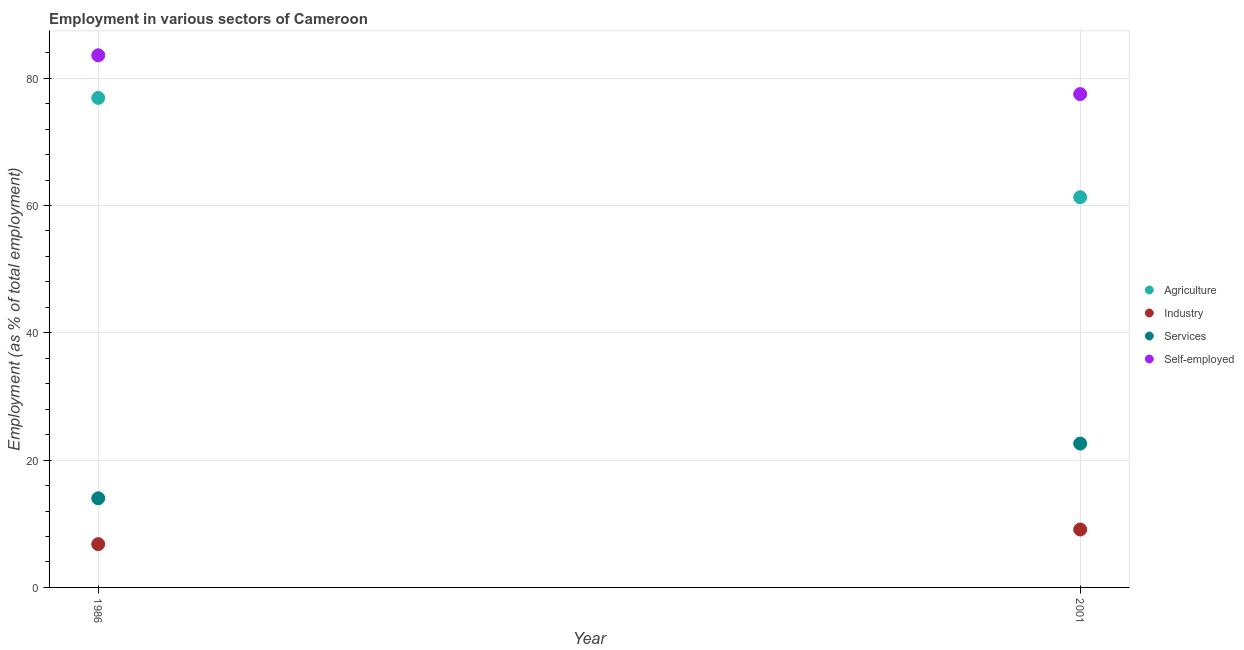How many different coloured dotlines are there?
Provide a succinct answer. 4. Is the number of dotlines equal to the number of legend labels?
Provide a succinct answer. Yes. What is the percentage of workers in industry in 1986?
Make the answer very short. 6.8. Across all years, what is the maximum percentage of workers in services?
Give a very brief answer. 22.6. Across all years, what is the minimum percentage of workers in industry?
Offer a very short reply. 6.8. In which year was the percentage of workers in services maximum?
Ensure brevity in your answer.  2001. In which year was the percentage of workers in services minimum?
Provide a succinct answer. 1986. What is the total percentage of workers in industry in the graph?
Provide a succinct answer. 15.9. What is the difference between the percentage of workers in industry in 1986 and that in 2001?
Give a very brief answer. -2.3. What is the difference between the percentage of workers in industry in 2001 and the percentage of self employed workers in 1986?
Your answer should be very brief. -74.5. What is the average percentage of workers in services per year?
Give a very brief answer. 18.3. In the year 1986, what is the difference between the percentage of self employed workers and percentage of workers in services?
Offer a terse response. 69.6. What is the ratio of the percentage of workers in agriculture in 1986 to that in 2001?
Give a very brief answer. 1.25. Is it the case that in every year, the sum of the percentage of self employed workers and percentage of workers in services is greater than the sum of percentage of workers in industry and percentage of workers in agriculture?
Provide a succinct answer. No. Is it the case that in every year, the sum of the percentage of workers in agriculture and percentage of workers in industry is greater than the percentage of workers in services?
Offer a terse response. Yes. Does the percentage of self employed workers monotonically increase over the years?
Keep it short and to the point. No. Is the percentage of self employed workers strictly greater than the percentage of workers in industry over the years?
Your answer should be very brief. Yes. How many dotlines are there?
Keep it short and to the point. 4. Are the values on the major ticks of Y-axis written in scientific E-notation?
Offer a very short reply. No. Does the graph contain any zero values?
Your answer should be compact. No. Where does the legend appear in the graph?
Make the answer very short. Center right. How many legend labels are there?
Your answer should be very brief. 4. What is the title of the graph?
Give a very brief answer. Employment in various sectors of Cameroon. What is the label or title of the X-axis?
Give a very brief answer. Year. What is the label or title of the Y-axis?
Your response must be concise. Employment (as % of total employment). What is the Employment (as % of total employment) of Agriculture in 1986?
Offer a very short reply. 76.9. What is the Employment (as % of total employment) of Industry in 1986?
Offer a very short reply. 6.8. What is the Employment (as % of total employment) of Services in 1986?
Ensure brevity in your answer.  14. What is the Employment (as % of total employment) of Self-employed in 1986?
Give a very brief answer. 83.6. What is the Employment (as % of total employment) in Agriculture in 2001?
Make the answer very short. 61.3. What is the Employment (as % of total employment) in Industry in 2001?
Offer a terse response. 9.1. What is the Employment (as % of total employment) of Services in 2001?
Provide a succinct answer. 22.6. What is the Employment (as % of total employment) of Self-employed in 2001?
Offer a very short reply. 77.5. Across all years, what is the maximum Employment (as % of total employment) of Agriculture?
Keep it short and to the point. 76.9. Across all years, what is the maximum Employment (as % of total employment) of Industry?
Offer a terse response. 9.1. Across all years, what is the maximum Employment (as % of total employment) of Services?
Give a very brief answer. 22.6. Across all years, what is the maximum Employment (as % of total employment) in Self-employed?
Offer a terse response. 83.6. Across all years, what is the minimum Employment (as % of total employment) in Agriculture?
Give a very brief answer. 61.3. Across all years, what is the minimum Employment (as % of total employment) of Industry?
Offer a terse response. 6.8. Across all years, what is the minimum Employment (as % of total employment) in Services?
Keep it short and to the point. 14. Across all years, what is the minimum Employment (as % of total employment) of Self-employed?
Provide a succinct answer. 77.5. What is the total Employment (as % of total employment) in Agriculture in the graph?
Your answer should be very brief. 138.2. What is the total Employment (as % of total employment) in Industry in the graph?
Make the answer very short. 15.9. What is the total Employment (as % of total employment) in Services in the graph?
Your answer should be compact. 36.6. What is the total Employment (as % of total employment) of Self-employed in the graph?
Ensure brevity in your answer.  161.1. What is the difference between the Employment (as % of total employment) in Self-employed in 1986 and that in 2001?
Make the answer very short. 6.1. What is the difference between the Employment (as % of total employment) of Agriculture in 1986 and the Employment (as % of total employment) of Industry in 2001?
Give a very brief answer. 67.8. What is the difference between the Employment (as % of total employment) in Agriculture in 1986 and the Employment (as % of total employment) in Services in 2001?
Your answer should be very brief. 54.3. What is the difference between the Employment (as % of total employment) in Industry in 1986 and the Employment (as % of total employment) in Services in 2001?
Ensure brevity in your answer.  -15.8. What is the difference between the Employment (as % of total employment) of Industry in 1986 and the Employment (as % of total employment) of Self-employed in 2001?
Your answer should be very brief. -70.7. What is the difference between the Employment (as % of total employment) of Services in 1986 and the Employment (as % of total employment) of Self-employed in 2001?
Give a very brief answer. -63.5. What is the average Employment (as % of total employment) of Agriculture per year?
Keep it short and to the point. 69.1. What is the average Employment (as % of total employment) in Industry per year?
Offer a terse response. 7.95. What is the average Employment (as % of total employment) in Services per year?
Give a very brief answer. 18.3. What is the average Employment (as % of total employment) in Self-employed per year?
Provide a short and direct response. 80.55. In the year 1986, what is the difference between the Employment (as % of total employment) in Agriculture and Employment (as % of total employment) in Industry?
Your answer should be very brief. 70.1. In the year 1986, what is the difference between the Employment (as % of total employment) of Agriculture and Employment (as % of total employment) of Services?
Keep it short and to the point. 62.9. In the year 1986, what is the difference between the Employment (as % of total employment) of Industry and Employment (as % of total employment) of Services?
Make the answer very short. -7.2. In the year 1986, what is the difference between the Employment (as % of total employment) in Industry and Employment (as % of total employment) in Self-employed?
Your answer should be very brief. -76.8. In the year 1986, what is the difference between the Employment (as % of total employment) of Services and Employment (as % of total employment) of Self-employed?
Your response must be concise. -69.6. In the year 2001, what is the difference between the Employment (as % of total employment) of Agriculture and Employment (as % of total employment) of Industry?
Your answer should be compact. 52.2. In the year 2001, what is the difference between the Employment (as % of total employment) of Agriculture and Employment (as % of total employment) of Services?
Provide a short and direct response. 38.7. In the year 2001, what is the difference between the Employment (as % of total employment) in Agriculture and Employment (as % of total employment) in Self-employed?
Ensure brevity in your answer.  -16.2. In the year 2001, what is the difference between the Employment (as % of total employment) of Industry and Employment (as % of total employment) of Services?
Provide a succinct answer. -13.5. In the year 2001, what is the difference between the Employment (as % of total employment) in Industry and Employment (as % of total employment) in Self-employed?
Keep it short and to the point. -68.4. In the year 2001, what is the difference between the Employment (as % of total employment) of Services and Employment (as % of total employment) of Self-employed?
Offer a very short reply. -54.9. What is the ratio of the Employment (as % of total employment) of Agriculture in 1986 to that in 2001?
Your response must be concise. 1.25. What is the ratio of the Employment (as % of total employment) in Industry in 1986 to that in 2001?
Make the answer very short. 0.75. What is the ratio of the Employment (as % of total employment) in Services in 1986 to that in 2001?
Offer a very short reply. 0.62. What is the ratio of the Employment (as % of total employment) of Self-employed in 1986 to that in 2001?
Provide a short and direct response. 1.08. What is the difference between the highest and the second highest Employment (as % of total employment) in Agriculture?
Provide a short and direct response. 15.6. What is the difference between the highest and the second highest Employment (as % of total employment) in Services?
Your response must be concise. 8.6. What is the difference between the highest and the second highest Employment (as % of total employment) of Self-employed?
Your response must be concise. 6.1. What is the difference between the highest and the lowest Employment (as % of total employment) in Agriculture?
Provide a short and direct response. 15.6. What is the difference between the highest and the lowest Employment (as % of total employment) of Industry?
Provide a short and direct response. 2.3. 